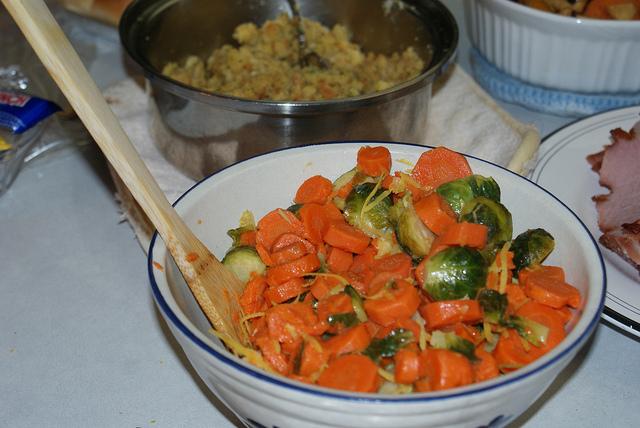What is in the bowl?
Quick response, please. Vegetables. Is the person eating this meal vegan?
Give a very brief answer. Yes. How many vegetables are in the bowl?
Give a very brief answer. 2. Is this meal vegetarian?
Be succinct. Yes. Are carrots in this photo?
Concise answer only. Yes. What is that brown food in the bowl?
Be succinct. Rice. Can you name one of the vegetables on this platter?
Give a very brief answer. Carrots. What utensil is being used?
Keep it brief. Spoon. 